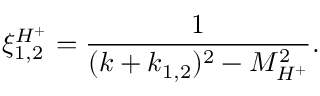Convert formula to latex. <formula><loc_0><loc_0><loc_500><loc_500>\xi _ { 1 , 2 } ^ { H ^ { + } } = \frac { 1 } { ( k + k _ { 1 , 2 } ) ^ { 2 } - M _ { H ^ { + } } ^ { 2 } } .</formula> 